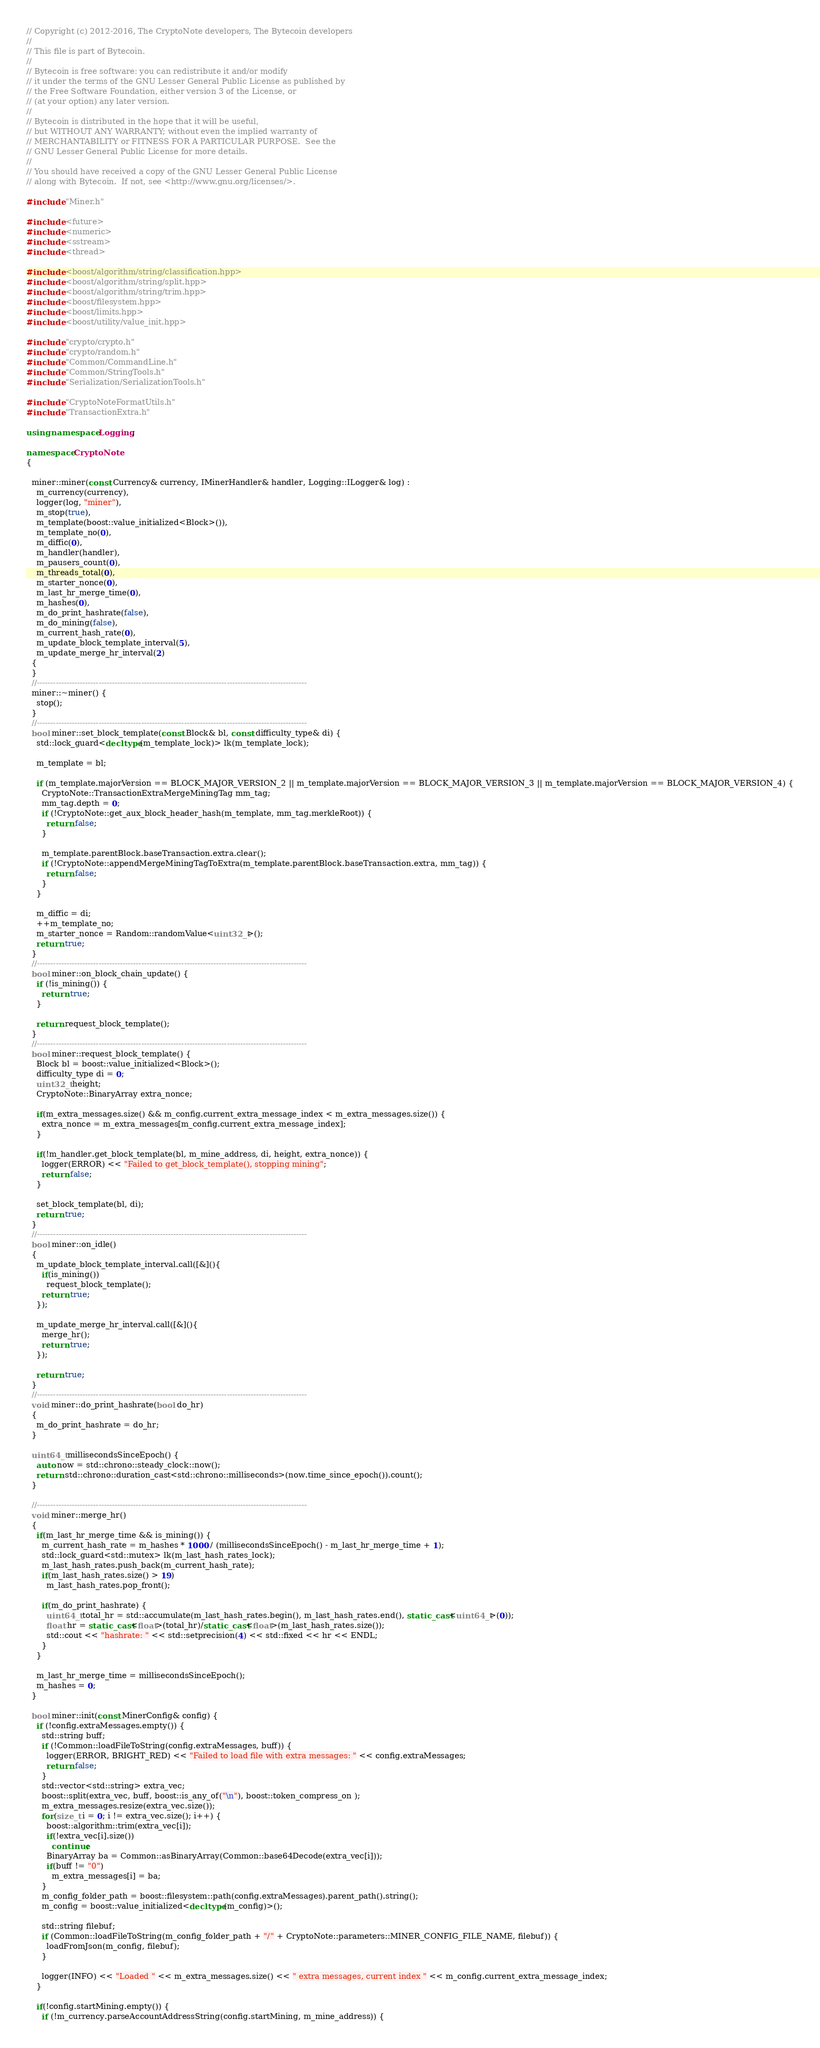<code> <loc_0><loc_0><loc_500><loc_500><_C++_>// Copyright (c) 2012-2016, The CryptoNote developers, The Bytecoin developers
//
// This file is part of Bytecoin.
//
// Bytecoin is free software: you can redistribute it and/or modify
// it under the terms of the GNU Lesser General Public License as published by
// the Free Software Foundation, either version 3 of the License, or
// (at your option) any later version.
//
// Bytecoin is distributed in the hope that it will be useful,
// but WITHOUT ANY WARRANTY; without even the implied warranty of
// MERCHANTABILITY or FITNESS FOR A PARTICULAR PURPOSE.  See the
// GNU Lesser General Public License for more details.
//
// You should have received a copy of the GNU Lesser General Public License
// along with Bytecoin.  If not, see <http://www.gnu.org/licenses/>.

#include "Miner.h"

#include <future>
#include <numeric>
#include <sstream>
#include <thread>

#include <boost/algorithm/string/classification.hpp>
#include <boost/algorithm/string/split.hpp>
#include <boost/algorithm/string/trim.hpp>
#include <boost/filesystem.hpp>
#include <boost/limits.hpp>
#include <boost/utility/value_init.hpp>

#include "crypto/crypto.h"
#include "crypto/random.h"
#include "Common/CommandLine.h"
#include "Common/StringTools.h"
#include "Serialization/SerializationTools.h"

#include "CryptoNoteFormatUtils.h"
#include "TransactionExtra.h"

using namespace Logging;

namespace CryptoNote
{

  miner::miner(const Currency& currency, IMinerHandler& handler, Logging::ILogger& log) :
    m_currency(currency),
    logger(log, "miner"),
    m_stop(true),
    m_template(boost::value_initialized<Block>()),
    m_template_no(0),
    m_diffic(0),
    m_handler(handler),
    m_pausers_count(0),
    m_threads_total(0),
    m_starter_nonce(0),
    m_last_hr_merge_time(0),
    m_hashes(0),
    m_do_print_hashrate(false),
    m_do_mining(false),
    m_current_hash_rate(0),
    m_update_block_template_interval(5),
    m_update_merge_hr_interval(2)
  {
  }
  //-----------------------------------------------------------------------------------------------------
  miner::~miner() {
    stop();
  }
  //-----------------------------------------------------------------------------------------------------
  bool miner::set_block_template(const Block& bl, const difficulty_type& di) {
    std::lock_guard<decltype(m_template_lock)> lk(m_template_lock);

    m_template = bl;

    if (m_template.majorVersion == BLOCK_MAJOR_VERSION_2 || m_template.majorVersion == BLOCK_MAJOR_VERSION_3 || m_template.majorVersion == BLOCK_MAJOR_VERSION_4) {
      CryptoNote::TransactionExtraMergeMiningTag mm_tag;
      mm_tag.depth = 0;
      if (!CryptoNote::get_aux_block_header_hash(m_template, mm_tag.merkleRoot)) {
        return false;
      }

      m_template.parentBlock.baseTransaction.extra.clear();
      if (!CryptoNote::appendMergeMiningTagToExtra(m_template.parentBlock.baseTransaction.extra, mm_tag)) {
        return false;
      }
    }

    m_diffic = di;
    ++m_template_no;
    m_starter_nonce = Random::randomValue<uint32_t>();
    return true;
  }
  //-----------------------------------------------------------------------------------------------------
  bool miner::on_block_chain_update() {
    if (!is_mining()) {
      return true;
    }

    return request_block_template();
  }
  //-----------------------------------------------------------------------------------------------------
  bool miner::request_block_template() {
    Block bl = boost::value_initialized<Block>();
    difficulty_type di = 0;
    uint32_t height;
    CryptoNote::BinaryArray extra_nonce;

    if(m_extra_messages.size() && m_config.current_extra_message_index < m_extra_messages.size()) {
      extra_nonce = m_extra_messages[m_config.current_extra_message_index];
    }

    if(!m_handler.get_block_template(bl, m_mine_address, di, height, extra_nonce)) {
      logger(ERROR) << "Failed to get_block_template(), stopping mining";
      return false;
    }

    set_block_template(bl, di);
    return true;
  }
  //-----------------------------------------------------------------------------------------------------
  bool miner::on_idle()
  {
    m_update_block_template_interval.call([&](){
      if(is_mining()) 
        request_block_template();
      return true;
    });

    m_update_merge_hr_interval.call([&](){
      merge_hr();
      return true;
    });

    return true;
  }
  //-----------------------------------------------------------------------------------------------------
  void miner::do_print_hashrate(bool do_hr)
  {
    m_do_print_hashrate = do_hr;
  }

  uint64_t millisecondsSinceEpoch() {
    auto now = std::chrono::steady_clock::now();
    return std::chrono::duration_cast<std::chrono::milliseconds>(now.time_since_epoch()).count();
  }

  //-----------------------------------------------------------------------------------------------------
  void miner::merge_hr()
  {
    if(m_last_hr_merge_time && is_mining()) {
      m_current_hash_rate = m_hashes * 1000 / (millisecondsSinceEpoch() - m_last_hr_merge_time + 1);
      std::lock_guard<std::mutex> lk(m_last_hash_rates_lock);
      m_last_hash_rates.push_back(m_current_hash_rate);
      if(m_last_hash_rates.size() > 19)
        m_last_hash_rates.pop_front();

      if(m_do_print_hashrate) {
        uint64_t total_hr = std::accumulate(m_last_hash_rates.begin(), m_last_hash_rates.end(), static_cast<uint64_t>(0));
        float hr = static_cast<float>(total_hr)/static_cast<float>(m_last_hash_rates.size());
        std::cout << "hashrate: " << std::setprecision(4) << std::fixed << hr << ENDL;
      }
    }
    
    m_last_hr_merge_time = millisecondsSinceEpoch();
    m_hashes = 0;
  }

  bool miner::init(const MinerConfig& config) {
    if (!config.extraMessages.empty()) {
      std::string buff;
      if (!Common::loadFileToString(config.extraMessages, buff)) {
        logger(ERROR, BRIGHT_RED) << "Failed to load file with extra messages: " << config.extraMessages; 
        return false; 
      }
      std::vector<std::string> extra_vec;
      boost::split(extra_vec, buff, boost::is_any_of("\n"), boost::token_compress_on );
      m_extra_messages.resize(extra_vec.size());
      for(size_t i = 0; i != extra_vec.size(); i++) {
        boost::algorithm::trim(extra_vec[i]);
        if(!extra_vec[i].size())
          continue;
        BinaryArray ba = Common::asBinaryArray(Common::base64Decode(extra_vec[i]));
        if(buff != "0")
          m_extra_messages[i] = ba;
      }
      m_config_folder_path = boost::filesystem::path(config.extraMessages).parent_path().string();
      m_config = boost::value_initialized<decltype(m_config)>();

      std::string filebuf;
      if (Common::loadFileToString(m_config_folder_path + "/" + CryptoNote::parameters::MINER_CONFIG_FILE_NAME, filebuf)) {
        loadFromJson(m_config, filebuf);
      }

      logger(INFO) << "Loaded " << m_extra_messages.size() << " extra messages, current index " << m_config.current_extra_message_index;
    }

    if(!config.startMining.empty()) {
      if (!m_currency.parseAccountAddressString(config.startMining, m_mine_address)) {</code> 